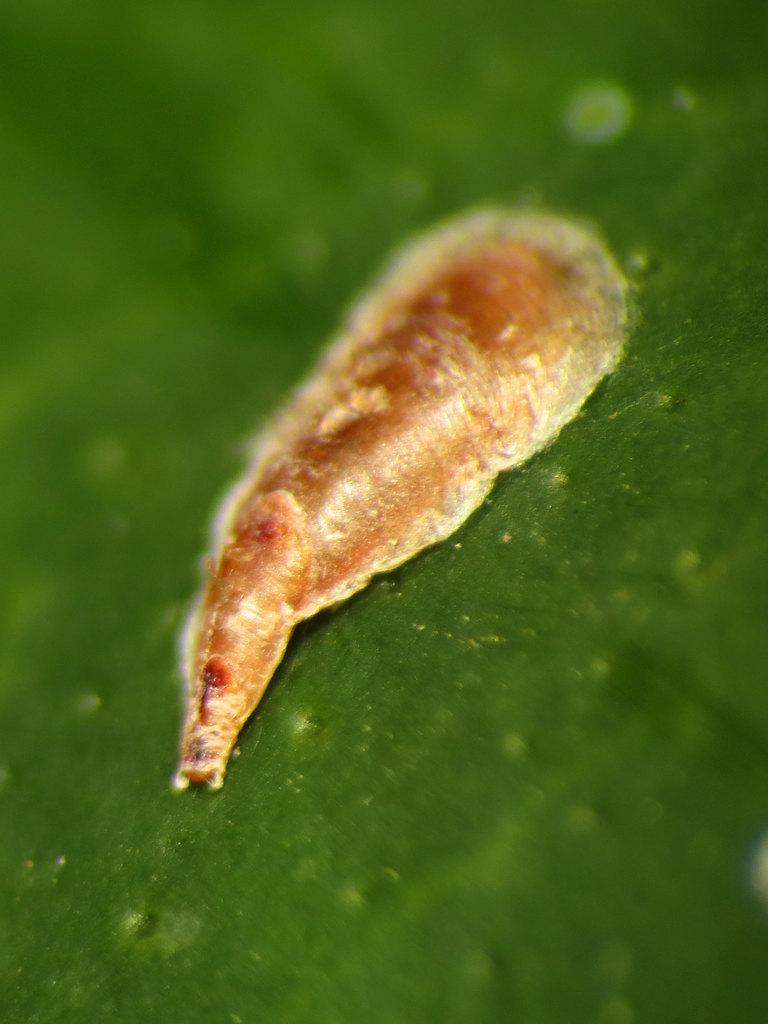What is the warm object placed on in the image? The warm object is placed on a green surface in the image. What colors can be seen in the background of the image? The background of the image is blue and green. What type of bag is being used by the expert in the image? There is no bag or expert present in the image. 